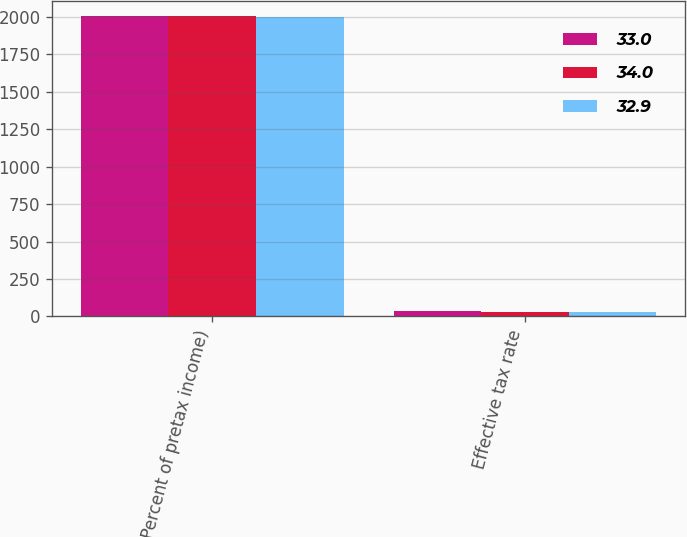Convert chart to OTSL. <chart><loc_0><loc_0><loc_500><loc_500><stacked_bar_chart><ecel><fcel>(Percent of pretax income)<fcel>Effective tax rate<nl><fcel>33<fcel>2005<fcel>34<nl><fcel>34<fcel>2004<fcel>33<nl><fcel>32.9<fcel>2003<fcel>32.9<nl></chart> 